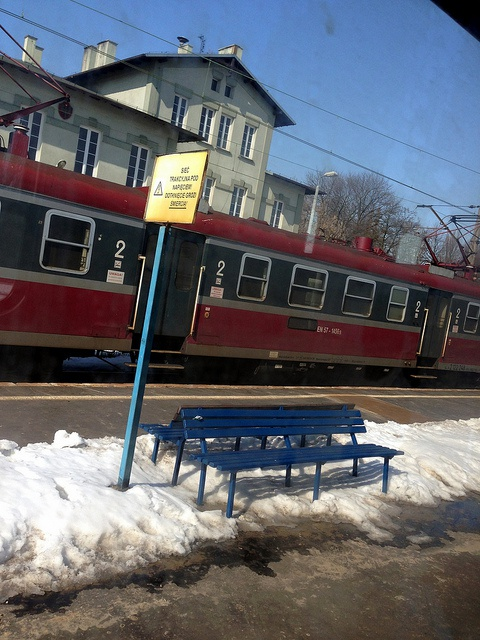Describe the objects in this image and their specific colors. I can see train in gray, black, and maroon tones, bench in gray, navy, black, and darkblue tones, and bench in gray, black, and navy tones in this image. 